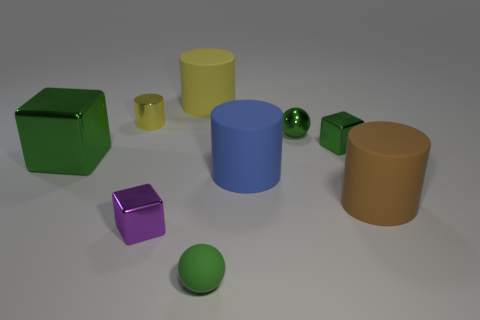Subtract all small blocks. How many blocks are left? 1 Add 1 yellow objects. How many objects exist? 10 Subtract all blue balls. How many green blocks are left? 2 Subtract all green cubes. How many cubes are left? 1 Subtract all balls. How many objects are left? 7 Subtract all red cylinders. Subtract all green blocks. How many cylinders are left? 4 Subtract all small green blocks. Subtract all small yellow cubes. How many objects are left? 8 Add 3 green balls. How many green balls are left? 5 Add 6 tiny brown cylinders. How many tiny brown cylinders exist? 6 Subtract 0 yellow blocks. How many objects are left? 9 